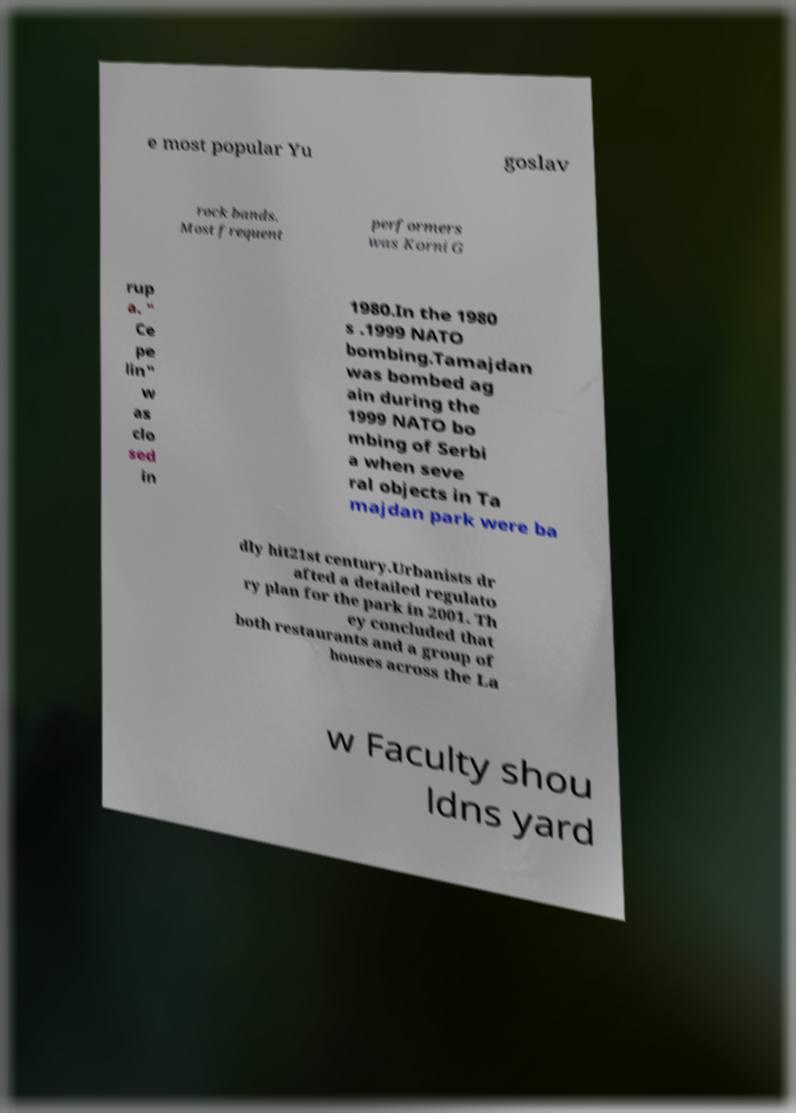I need the written content from this picture converted into text. Can you do that? e most popular Yu goslav rock bands. Most frequent performers was Korni G rup a. " Ce pe lin" w as clo sed in 1980.In the 1980 s .1999 NATO bombing.Tamajdan was bombed ag ain during the 1999 NATO bo mbing of Serbi a when seve ral objects in Ta majdan park were ba dly hit21st century.Urbanists dr afted a detailed regulato ry plan for the park in 2001. Th ey concluded that both restaurants and a group of houses across the La w Faculty shou ldns yard 